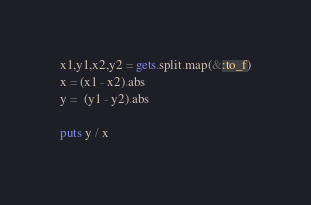Convert code to text. <code><loc_0><loc_0><loc_500><loc_500><_Ruby_>x1,y1,x2,y2 = gets.split.map(&:to_f)
x = (x1 - x2).abs
y =  (y1 - y2).abs

puts y / x
</code> 